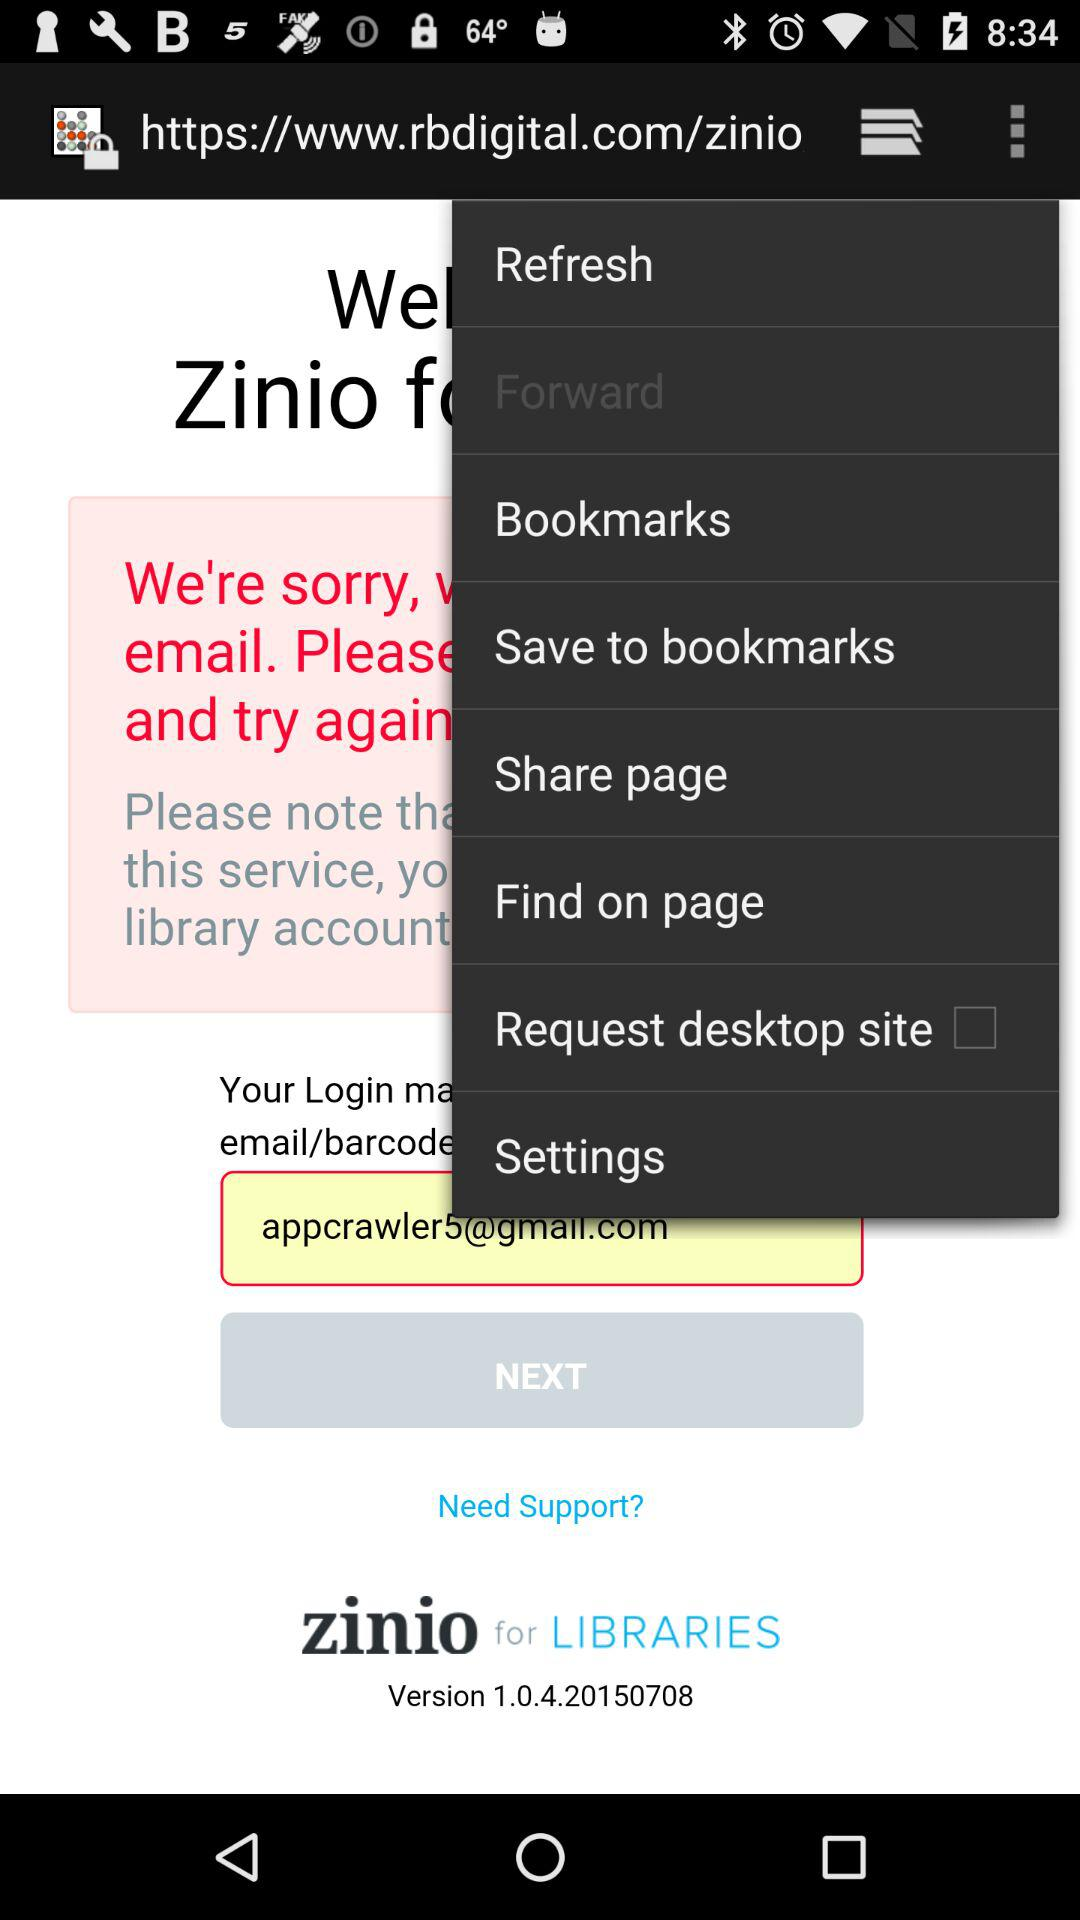What is the email address? The email address is appcrawler5@gmail.com. 